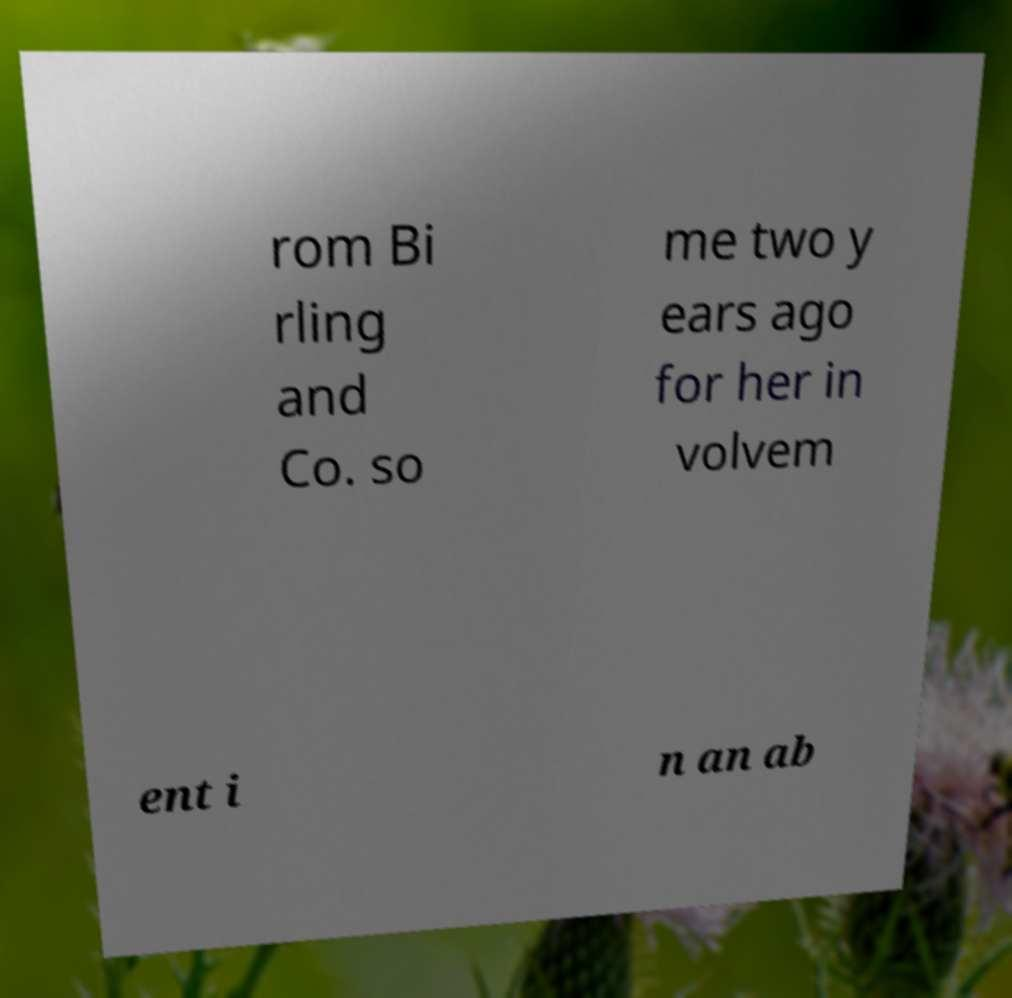Can you read and provide the text displayed in the image?This photo seems to have some interesting text. Can you extract and type it out for me? rom Bi rling and Co. so me two y ears ago for her in volvem ent i n an ab 